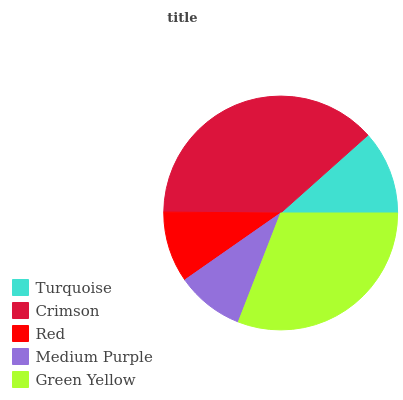Is Medium Purple the minimum?
Answer yes or no. Yes. Is Crimson the maximum?
Answer yes or no. Yes. Is Red the minimum?
Answer yes or no. No. Is Red the maximum?
Answer yes or no. No. Is Crimson greater than Red?
Answer yes or no. Yes. Is Red less than Crimson?
Answer yes or no. Yes. Is Red greater than Crimson?
Answer yes or no. No. Is Crimson less than Red?
Answer yes or no. No. Is Turquoise the high median?
Answer yes or no. Yes. Is Turquoise the low median?
Answer yes or no. Yes. Is Crimson the high median?
Answer yes or no. No. Is Medium Purple the low median?
Answer yes or no. No. 